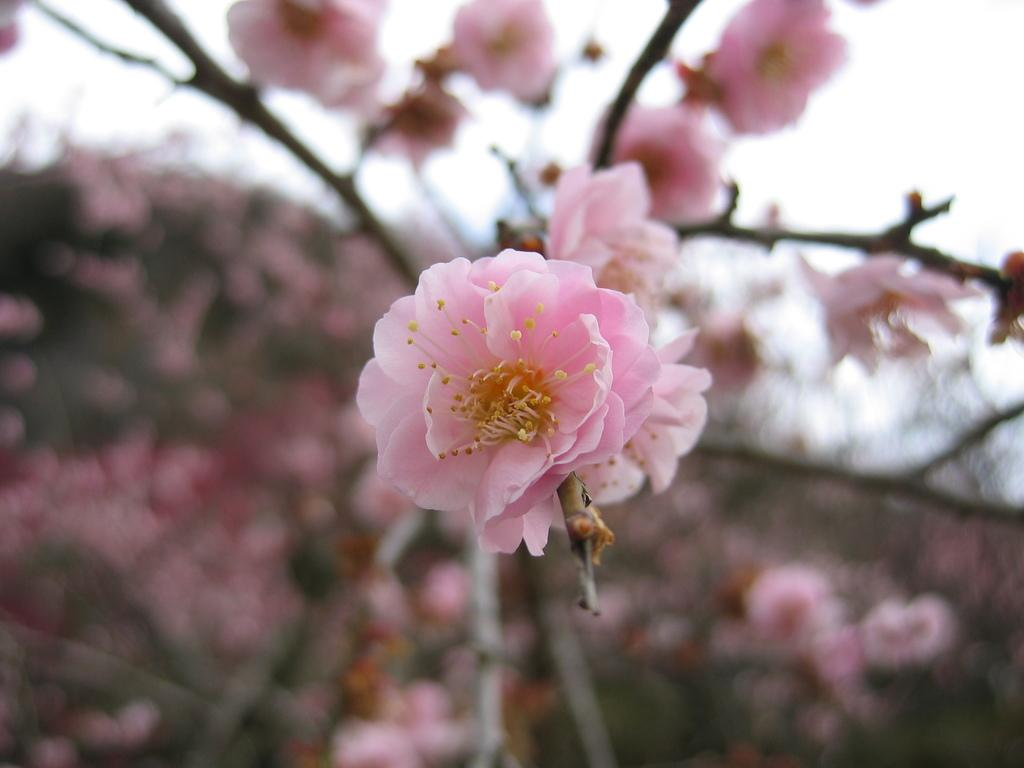What is present in the image? There are flowers in the image. Can you describe the background of the image? The background of the image is blurry. What insect can be seen teaching a class in the image? There is no insect or teaching activity present in the image; it only features flowers and a blurry background. 